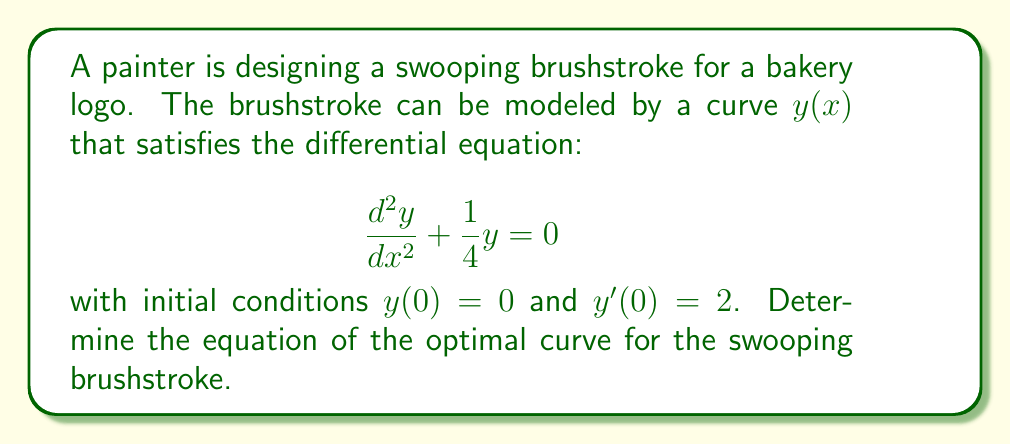Help me with this question. To solve this differential equation, we follow these steps:

1) The given differential equation is a second-order linear homogeneous equation with constant coefficients. Its characteristic equation is:

   $$r^2 + \frac{1}{4} = 0$$

2) Solving this equation:
   $$r = \pm \frac{i}{2}$$

3) The general solution to this differential equation is:

   $$y(x) = C_1 \cos(\frac{x}{2}) + C_2 \sin(\frac{x}{2})$$

   where $C_1$ and $C_2$ are constants to be determined from the initial conditions.

4) Given initial conditions:
   $y(0) = 0$ and $y'(0) = 2$

5) Applying the first condition $y(0) = 0$:
   $$0 = C_1 \cos(0) + C_2 \sin(0) = C_1$$
   Therefore, $C_1 = 0$

6) To use the second condition, we need to find $y'(x)$:
   $$y'(x) = -\frac{1}{2}C_1 \sin(\frac{x}{2}) + \frac{1}{2}C_2 \cos(\frac{x}{2})$$

7) Applying the second condition $y'(0) = 2$:
   $$2 = \frac{1}{2}C_2$$
   Therefore, $C_2 = 4$

8) Substituting these values back into the general solution:

   $$y(x) = 4 \sin(\frac{x}{2})$$

This equation represents the optimal curve for the swooping brushstroke in the bakery logo.
Answer: $y(x) = 4 \sin(\frac{x}{2})$ 